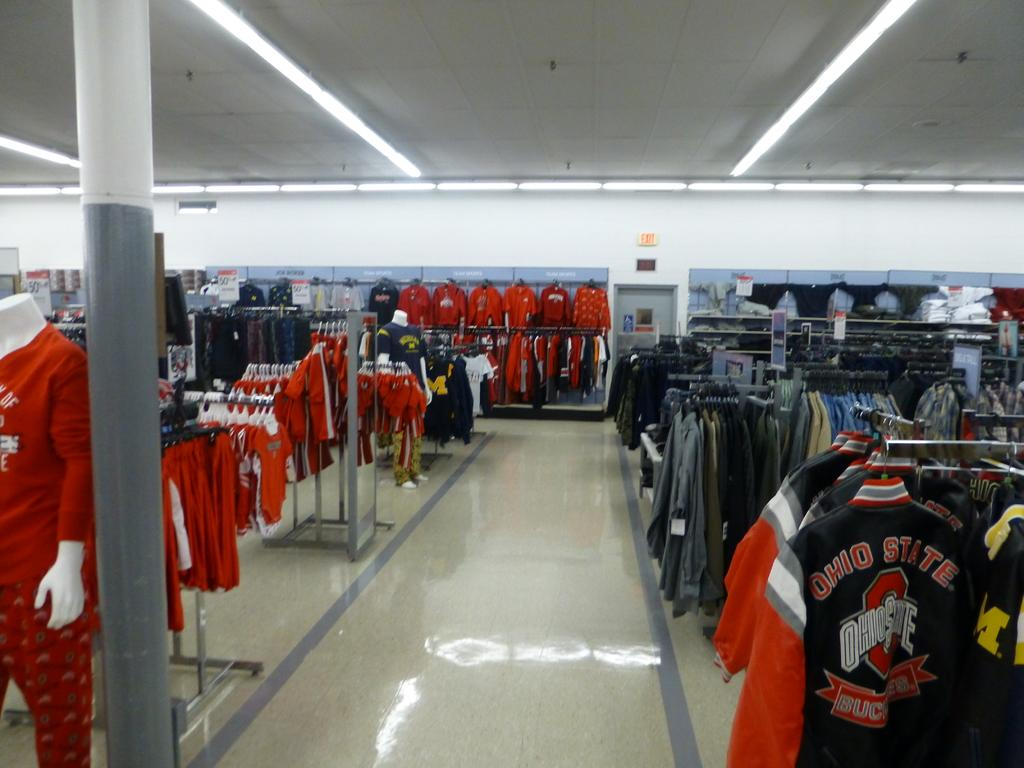<image>
Give a short and clear explanation of the subsequent image. From the center aisle of this department store, Ohio State apparel can be seen to the left, right, and front in the women's, men's, and children's department's. 